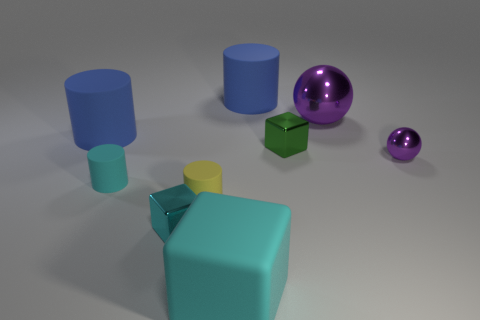There is a large rubber object that is the same shape as the green shiny object; what color is it?
Offer a terse response. Cyan. How many other things are there of the same material as the yellow object?
Keep it short and to the point. 4. Are there any small rubber cylinders that have the same color as the tiny metallic ball?
Offer a very short reply. No. Does the big sphere have the same material as the tiny cyan object that is behind the small yellow matte object?
Keep it short and to the point. No. There is a big blue matte cylinder to the left of the yellow rubber thing; are there any tiny green metallic objects that are to the left of it?
Ensure brevity in your answer.  No. The small thing that is behind the cyan metal object and to the left of the tiny yellow thing is what color?
Your response must be concise. Cyan. How big is the cyan cylinder?
Keep it short and to the point. Small. What number of green shiny spheres are the same size as the yellow matte cylinder?
Keep it short and to the point. 0. Are the large cyan cube in front of the small green block and the cube that is on the left side of the large cyan rubber block made of the same material?
Provide a succinct answer. No. There is a ball in front of the purple shiny sphere that is behind the green shiny cube; what is it made of?
Your response must be concise. Metal. 